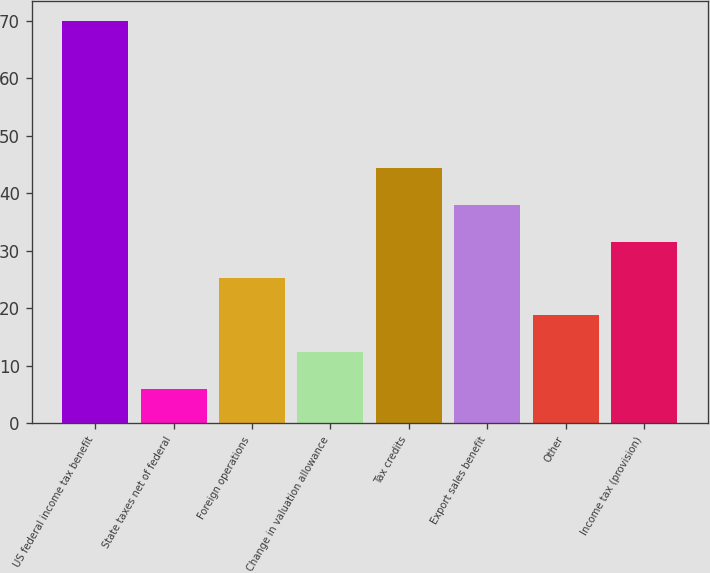<chart> <loc_0><loc_0><loc_500><loc_500><bar_chart><fcel>US federal income tax benefit<fcel>State taxes net of federal<fcel>Foreign operations<fcel>Change in valuation allowance<fcel>Tax credits<fcel>Export sales benefit<fcel>Other<fcel>Income tax (provision)<nl><fcel>70<fcel>6<fcel>25.2<fcel>12.4<fcel>44.4<fcel>38<fcel>18.8<fcel>31.6<nl></chart> 